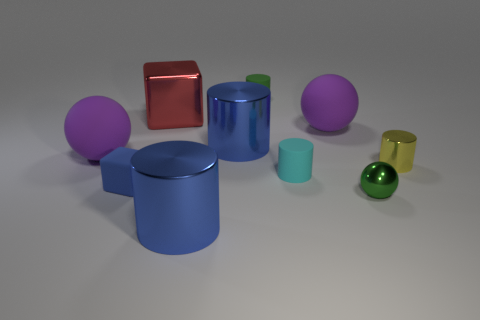Do the tiny yellow cylinder and the small block have the same material?
Keep it short and to the point. No. What number of matte objects are small balls or cyan things?
Ensure brevity in your answer.  1. There is a object that is the same color as the small ball; what shape is it?
Your response must be concise. Cylinder. There is a metallic cylinder in front of the tiny yellow metal cylinder; is it the same color as the rubber block?
Your answer should be very brief. Yes. There is a small object that is right of the small green object in front of the tiny blue rubber thing; what shape is it?
Provide a succinct answer. Cylinder. How many things are big blue cylinders behind the tiny blue rubber object or cylinders behind the tiny blue matte cube?
Offer a terse response. 4. The small blue object that is the same material as the tiny green cylinder is what shape?
Make the answer very short. Cube. Is there anything else that has the same color as the metal cube?
Provide a short and direct response. No. There is a small yellow object that is the same shape as the tiny cyan object; what is its material?
Make the answer very short. Metal. What number of other objects are there of the same size as the green rubber cylinder?
Offer a very short reply. 4. 